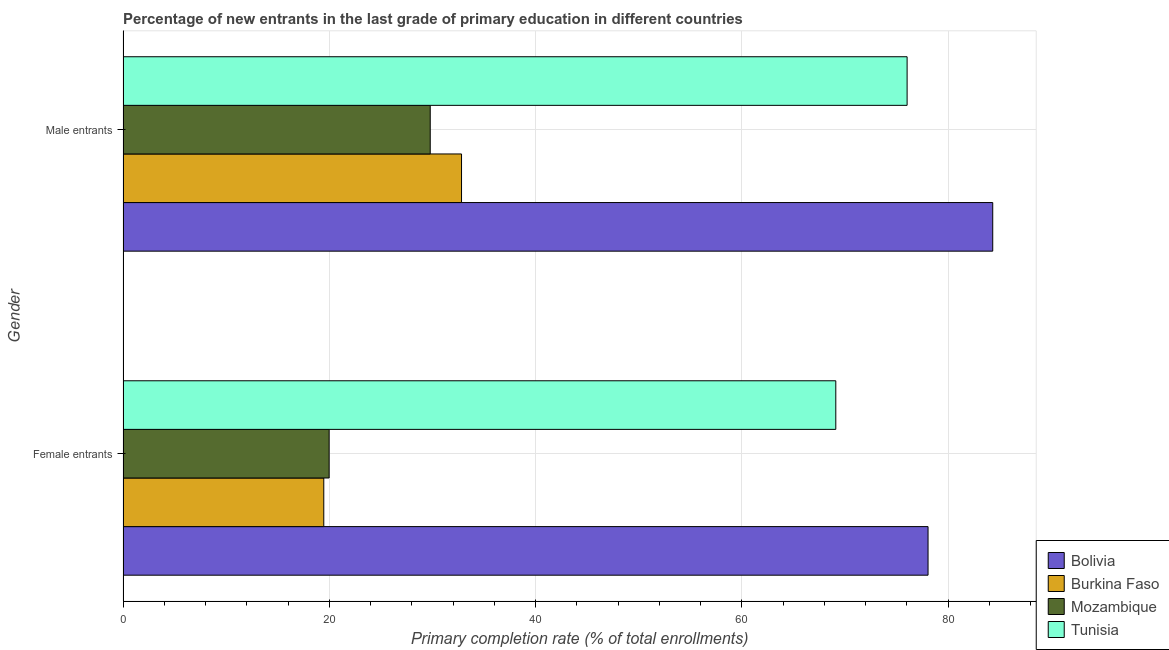How many different coloured bars are there?
Keep it short and to the point. 4. How many groups of bars are there?
Make the answer very short. 2. Are the number of bars per tick equal to the number of legend labels?
Provide a short and direct response. Yes. What is the label of the 1st group of bars from the top?
Give a very brief answer. Male entrants. What is the primary completion rate of female entrants in Tunisia?
Your response must be concise. 69.1. Across all countries, what is the maximum primary completion rate of male entrants?
Your answer should be compact. 84.32. Across all countries, what is the minimum primary completion rate of male entrants?
Ensure brevity in your answer.  29.79. In which country was the primary completion rate of female entrants minimum?
Offer a terse response. Burkina Faso. What is the total primary completion rate of female entrants in the graph?
Offer a terse response. 186.61. What is the difference between the primary completion rate of female entrants in Burkina Faso and that in Tunisia?
Give a very brief answer. -49.64. What is the difference between the primary completion rate of female entrants in Bolivia and the primary completion rate of male entrants in Burkina Faso?
Your answer should be compact. 45.23. What is the average primary completion rate of male entrants per country?
Keep it short and to the point. 55.74. What is the difference between the primary completion rate of male entrants and primary completion rate of female entrants in Burkina Faso?
Offer a very short reply. 13.35. In how many countries, is the primary completion rate of male entrants greater than 72 %?
Offer a very short reply. 2. What is the ratio of the primary completion rate of male entrants in Mozambique to that in Bolivia?
Your response must be concise. 0.35. What does the 1st bar from the top in Female entrants represents?
Your response must be concise. Tunisia. What does the 1st bar from the bottom in Female entrants represents?
Provide a succinct answer. Bolivia. How many countries are there in the graph?
Your answer should be compact. 4. Are the values on the major ticks of X-axis written in scientific E-notation?
Ensure brevity in your answer.  No. Where does the legend appear in the graph?
Your answer should be compact. Bottom right. How many legend labels are there?
Your answer should be very brief. 4. What is the title of the graph?
Provide a short and direct response. Percentage of new entrants in the last grade of primary education in different countries. Does "Ireland" appear as one of the legend labels in the graph?
Ensure brevity in your answer.  No. What is the label or title of the X-axis?
Offer a terse response. Primary completion rate (% of total enrollments). What is the Primary completion rate (% of total enrollments) in Bolivia in Female entrants?
Offer a very short reply. 78.05. What is the Primary completion rate (% of total enrollments) of Burkina Faso in Female entrants?
Offer a very short reply. 19.47. What is the Primary completion rate (% of total enrollments) in Mozambique in Female entrants?
Give a very brief answer. 19.98. What is the Primary completion rate (% of total enrollments) in Tunisia in Female entrants?
Provide a short and direct response. 69.1. What is the Primary completion rate (% of total enrollments) of Bolivia in Male entrants?
Your response must be concise. 84.32. What is the Primary completion rate (% of total enrollments) in Burkina Faso in Male entrants?
Make the answer very short. 32.82. What is the Primary completion rate (% of total enrollments) of Mozambique in Male entrants?
Keep it short and to the point. 29.79. What is the Primary completion rate (% of total enrollments) of Tunisia in Male entrants?
Provide a short and direct response. 76.02. Across all Gender, what is the maximum Primary completion rate (% of total enrollments) in Bolivia?
Offer a very short reply. 84.32. Across all Gender, what is the maximum Primary completion rate (% of total enrollments) of Burkina Faso?
Make the answer very short. 32.82. Across all Gender, what is the maximum Primary completion rate (% of total enrollments) in Mozambique?
Your answer should be compact. 29.79. Across all Gender, what is the maximum Primary completion rate (% of total enrollments) in Tunisia?
Your answer should be very brief. 76.02. Across all Gender, what is the minimum Primary completion rate (% of total enrollments) of Bolivia?
Your answer should be compact. 78.05. Across all Gender, what is the minimum Primary completion rate (% of total enrollments) of Burkina Faso?
Ensure brevity in your answer.  19.47. Across all Gender, what is the minimum Primary completion rate (% of total enrollments) in Mozambique?
Your response must be concise. 19.98. Across all Gender, what is the minimum Primary completion rate (% of total enrollments) in Tunisia?
Provide a short and direct response. 69.1. What is the total Primary completion rate (% of total enrollments) in Bolivia in the graph?
Offer a terse response. 162.37. What is the total Primary completion rate (% of total enrollments) of Burkina Faso in the graph?
Your answer should be very brief. 52.29. What is the total Primary completion rate (% of total enrollments) in Mozambique in the graph?
Provide a succinct answer. 49.77. What is the total Primary completion rate (% of total enrollments) in Tunisia in the graph?
Your answer should be very brief. 145.12. What is the difference between the Primary completion rate (% of total enrollments) of Bolivia in Female entrants and that in Male entrants?
Offer a terse response. -6.27. What is the difference between the Primary completion rate (% of total enrollments) of Burkina Faso in Female entrants and that in Male entrants?
Your answer should be very brief. -13.35. What is the difference between the Primary completion rate (% of total enrollments) of Mozambique in Female entrants and that in Male entrants?
Provide a short and direct response. -9.8. What is the difference between the Primary completion rate (% of total enrollments) of Tunisia in Female entrants and that in Male entrants?
Give a very brief answer. -6.91. What is the difference between the Primary completion rate (% of total enrollments) of Bolivia in Female entrants and the Primary completion rate (% of total enrollments) of Burkina Faso in Male entrants?
Your response must be concise. 45.23. What is the difference between the Primary completion rate (% of total enrollments) of Bolivia in Female entrants and the Primary completion rate (% of total enrollments) of Mozambique in Male entrants?
Give a very brief answer. 48.26. What is the difference between the Primary completion rate (% of total enrollments) in Bolivia in Female entrants and the Primary completion rate (% of total enrollments) in Tunisia in Male entrants?
Make the answer very short. 2.03. What is the difference between the Primary completion rate (% of total enrollments) of Burkina Faso in Female entrants and the Primary completion rate (% of total enrollments) of Mozambique in Male entrants?
Your response must be concise. -10.32. What is the difference between the Primary completion rate (% of total enrollments) of Burkina Faso in Female entrants and the Primary completion rate (% of total enrollments) of Tunisia in Male entrants?
Your response must be concise. -56.55. What is the difference between the Primary completion rate (% of total enrollments) of Mozambique in Female entrants and the Primary completion rate (% of total enrollments) of Tunisia in Male entrants?
Offer a very short reply. -56.03. What is the average Primary completion rate (% of total enrollments) of Bolivia per Gender?
Your response must be concise. 81.19. What is the average Primary completion rate (% of total enrollments) of Burkina Faso per Gender?
Your answer should be very brief. 26.14. What is the average Primary completion rate (% of total enrollments) in Mozambique per Gender?
Make the answer very short. 24.89. What is the average Primary completion rate (% of total enrollments) in Tunisia per Gender?
Provide a succinct answer. 72.56. What is the difference between the Primary completion rate (% of total enrollments) of Bolivia and Primary completion rate (% of total enrollments) of Burkina Faso in Female entrants?
Give a very brief answer. 58.58. What is the difference between the Primary completion rate (% of total enrollments) in Bolivia and Primary completion rate (% of total enrollments) in Mozambique in Female entrants?
Provide a short and direct response. 58.06. What is the difference between the Primary completion rate (% of total enrollments) of Bolivia and Primary completion rate (% of total enrollments) of Tunisia in Female entrants?
Make the answer very short. 8.94. What is the difference between the Primary completion rate (% of total enrollments) of Burkina Faso and Primary completion rate (% of total enrollments) of Mozambique in Female entrants?
Keep it short and to the point. -0.52. What is the difference between the Primary completion rate (% of total enrollments) in Burkina Faso and Primary completion rate (% of total enrollments) in Tunisia in Female entrants?
Provide a short and direct response. -49.64. What is the difference between the Primary completion rate (% of total enrollments) in Mozambique and Primary completion rate (% of total enrollments) in Tunisia in Female entrants?
Your answer should be very brief. -49.12. What is the difference between the Primary completion rate (% of total enrollments) in Bolivia and Primary completion rate (% of total enrollments) in Burkina Faso in Male entrants?
Provide a short and direct response. 51.5. What is the difference between the Primary completion rate (% of total enrollments) in Bolivia and Primary completion rate (% of total enrollments) in Mozambique in Male entrants?
Keep it short and to the point. 54.53. What is the difference between the Primary completion rate (% of total enrollments) of Bolivia and Primary completion rate (% of total enrollments) of Tunisia in Male entrants?
Offer a terse response. 8.3. What is the difference between the Primary completion rate (% of total enrollments) of Burkina Faso and Primary completion rate (% of total enrollments) of Mozambique in Male entrants?
Make the answer very short. 3.04. What is the difference between the Primary completion rate (% of total enrollments) of Burkina Faso and Primary completion rate (% of total enrollments) of Tunisia in Male entrants?
Offer a terse response. -43.2. What is the difference between the Primary completion rate (% of total enrollments) of Mozambique and Primary completion rate (% of total enrollments) of Tunisia in Male entrants?
Offer a terse response. -46.23. What is the ratio of the Primary completion rate (% of total enrollments) of Bolivia in Female entrants to that in Male entrants?
Make the answer very short. 0.93. What is the ratio of the Primary completion rate (% of total enrollments) in Burkina Faso in Female entrants to that in Male entrants?
Keep it short and to the point. 0.59. What is the ratio of the Primary completion rate (% of total enrollments) in Mozambique in Female entrants to that in Male entrants?
Your answer should be very brief. 0.67. What is the ratio of the Primary completion rate (% of total enrollments) of Tunisia in Female entrants to that in Male entrants?
Your answer should be very brief. 0.91. What is the difference between the highest and the second highest Primary completion rate (% of total enrollments) in Bolivia?
Offer a terse response. 6.27. What is the difference between the highest and the second highest Primary completion rate (% of total enrollments) of Burkina Faso?
Offer a terse response. 13.35. What is the difference between the highest and the second highest Primary completion rate (% of total enrollments) of Mozambique?
Keep it short and to the point. 9.8. What is the difference between the highest and the second highest Primary completion rate (% of total enrollments) of Tunisia?
Give a very brief answer. 6.91. What is the difference between the highest and the lowest Primary completion rate (% of total enrollments) of Bolivia?
Provide a succinct answer. 6.27. What is the difference between the highest and the lowest Primary completion rate (% of total enrollments) of Burkina Faso?
Make the answer very short. 13.35. What is the difference between the highest and the lowest Primary completion rate (% of total enrollments) of Mozambique?
Provide a short and direct response. 9.8. What is the difference between the highest and the lowest Primary completion rate (% of total enrollments) in Tunisia?
Provide a short and direct response. 6.91. 